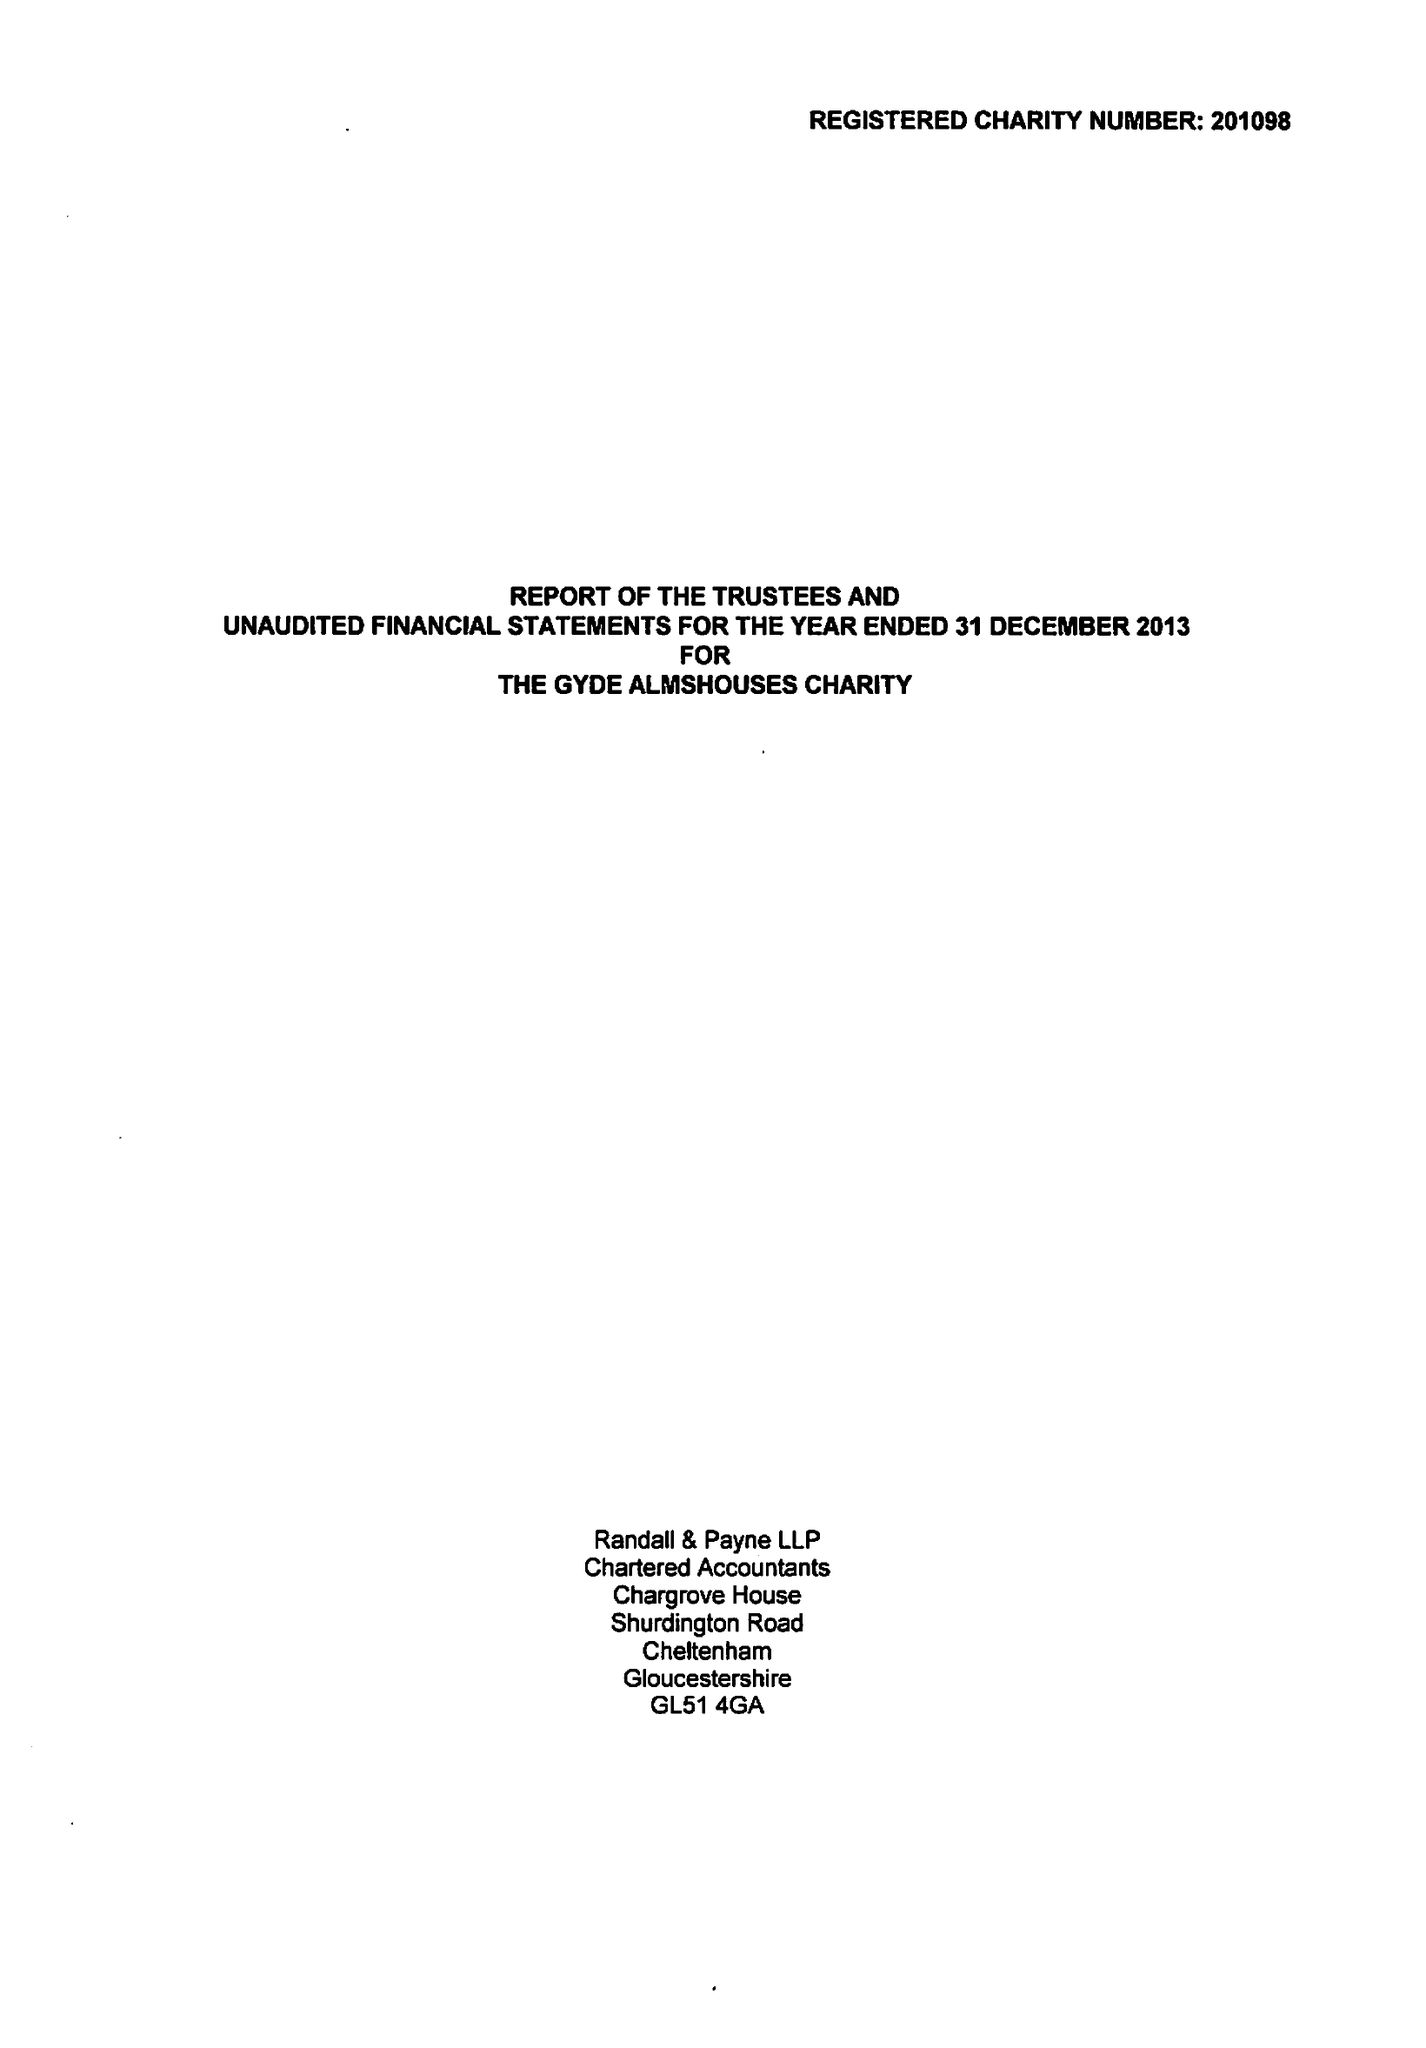What is the value for the income_annually_in_british_pounds?
Answer the question using a single word or phrase. 29767.00 